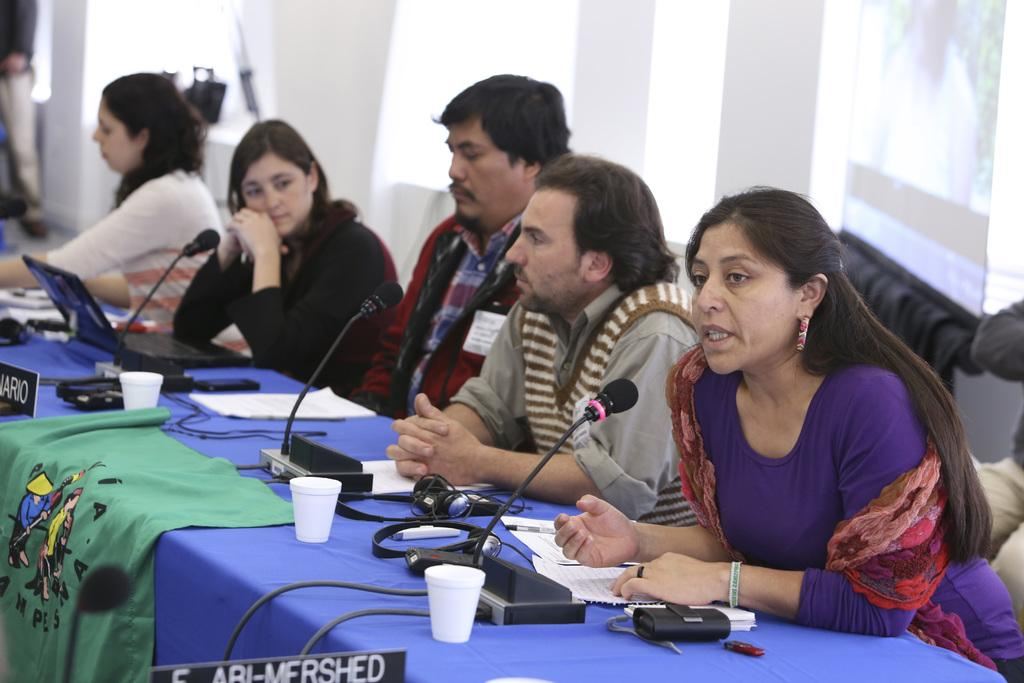What are the persons in the image doing? The persons in the image are sitting. Where are the persons sitting in relation to the table? The persons are sitting in front of a table. What can be seen on the table in the image? There is a mic, cups, and papers on the table. What is on the wall behind the persons? There is: There is a screen on the wall behind the persons. What degrees do the persons sitting in the image have? There is no information about the persons' degrees in the image. How many planes are flying in the image? There are no planes visible in the image. 